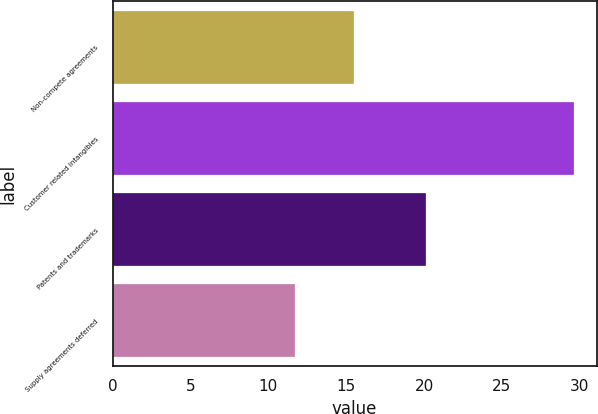Convert chart to OTSL. <chart><loc_0><loc_0><loc_500><loc_500><bar_chart><fcel>Non-compete agreements<fcel>Customer related intangibles<fcel>Patents and trademarks<fcel>Supply agreements deferred<nl><fcel>15.5<fcel>29.6<fcel>20.1<fcel>11.7<nl></chart> 